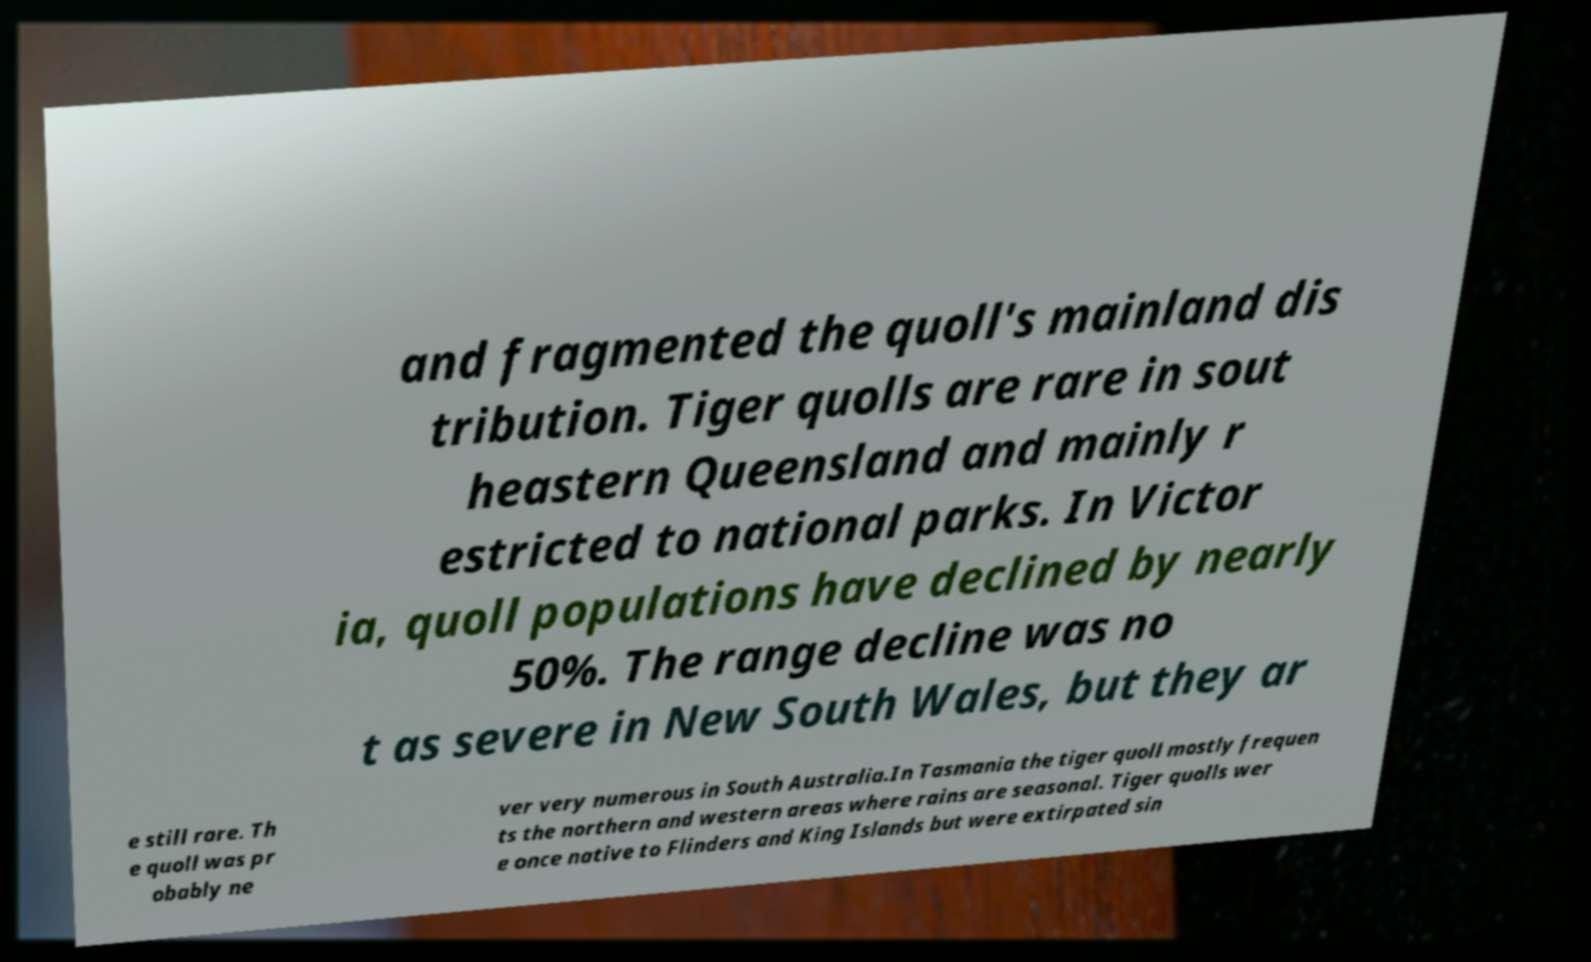Please identify and transcribe the text found in this image. and fragmented the quoll's mainland dis tribution. Tiger quolls are rare in sout heastern Queensland and mainly r estricted to national parks. In Victor ia, quoll populations have declined by nearly 50%. The range decline was no t as severe in New South Wales, but they ar e still rare. Th e quoll was pr obably ne ver very numerous in South Australia.In Tasmania the tiger quoll mostly frequen ts the northern and western areas where rains are seasonal. Tiger quolls wer e once native to Flinders and King Islands but were extirpated sin 